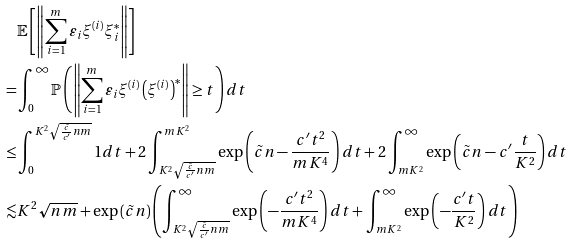<formula> <loc_0><loc_0><loc_500><loc_500>& \mathbb { E } \left [ \left \| \sum _ { i = 1 } ^ { m } \varepsilon _ { i } \xi ^ { \left ( i \right ) } \xi ^ { * } _ { i } \right \| \right ] \\ = & \int _ { 0 } ^ { \infty } \mathbb { P } \left ( \left \| \sum _ { i = 1 } ^ { m } \varepsilon _ { i } \xi ^ { \left ( i \right ) } \left ( \xi ^ { \left ( i \right ) } \right ) ^ { * } \right \| \geq t \right ) d t \\ \leq & \int _ { 0 } ^ { K ^ { 2 } \sqrt { \frac { \tilde { c } } { c ^ { \prime } } n m } } 1 d t + 2 \int _ { K ^ { 2 } \sqrt { \frac { \tilde { c } } { c ^ { \prime } } n m } } ^ { m K ^ { 2 } } \exp \left ( \tilde { c } n - \frac { c ^ { \prime } t ^ { 2 } } { m K ^ { 4 } } \right ) d t + 2 \int _ { m K ^ { 2 } } ^ { \infty } \exp \left ( \tilde { c } n - c ^ { \prime } \frac { t } { K ^ { 2 } } \right ) d t \\ \lesssim & K ^ { 2 } \sqrt { n m } + \exp \left ( \tilde { c } n \right ) \left ( \int _ { K ^ { 2 } \sqrt { \frac { \tilde { c } } { c ^ { \prime } } n m } } ^ { \infty } \exp \left ( - \frac { c ^ { \prime } t ^ { 2 } } { m K ^ { 4 } } \right ) d t + \int _ { m K ^ { 2 } } ^ { \infty } \exp \left ( - \frac { c ^ { \prime } t } { K ^ { 2 } } \right ) d t \right )</formula> 